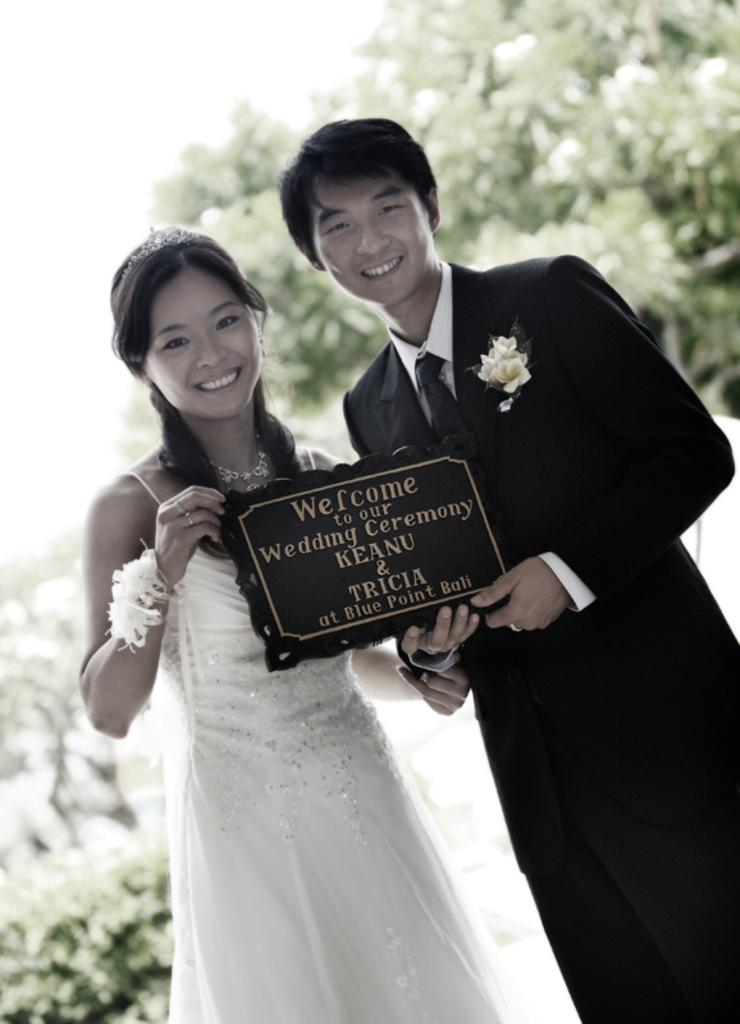What is happening in the image? There are persons standing in the image. What are the persons holding? The persons are holding a frame with text written in it. What can be seen in the background of the image? There are trees visible in the background of the image. What type of trousers are the actors wearing in the image? There are no actors present in the image, and therefore no information about their trousers can be provided. How many ducks can be seen swimming in the background of the image? There are no ducks present in the image; the background features trees. 